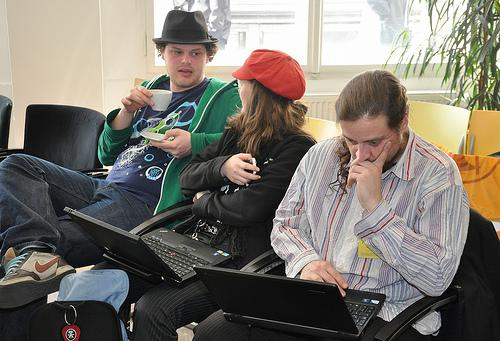Question: what do the two people on left appear to be doing?
Choices:
A. Having conversation.
B. Playing wii.
C. Eating.
D. Kissing.
Answer with the letter. Answer: A Question: when was this photo taken?
Choices:
A. Last year.
B. Yesterday.
C. Daylight.
D. At night.
Answer with the letter. Answer: C Question: where are the people sitting?
Choices:
A. On the couch.
B. On the beach.
C. Chairs.
D. On the bench.
Answer with the letter. Answer: C Question: who is the person in the middle?
Choices:
A. A policeman.
B. Woman.
C. A firefighter.
D. A nurse.
Answer with the letter. Answer: B Question: how many people are in this photo?
Choices:
A. 4.
B. 5.
C. 6.
D. 3.
Answer with the letter. Answer: D 